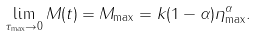Convert formula to latex. <formula><loc_0><loc_0><loc_500><loc_500>\lim _ { \tau _ { \max } \rightarrow 0 } M ( t ) = M _ { \max } = k ( 1 - \alpha ) \eta _ { \max } ^ { \alpha } .</formula> 